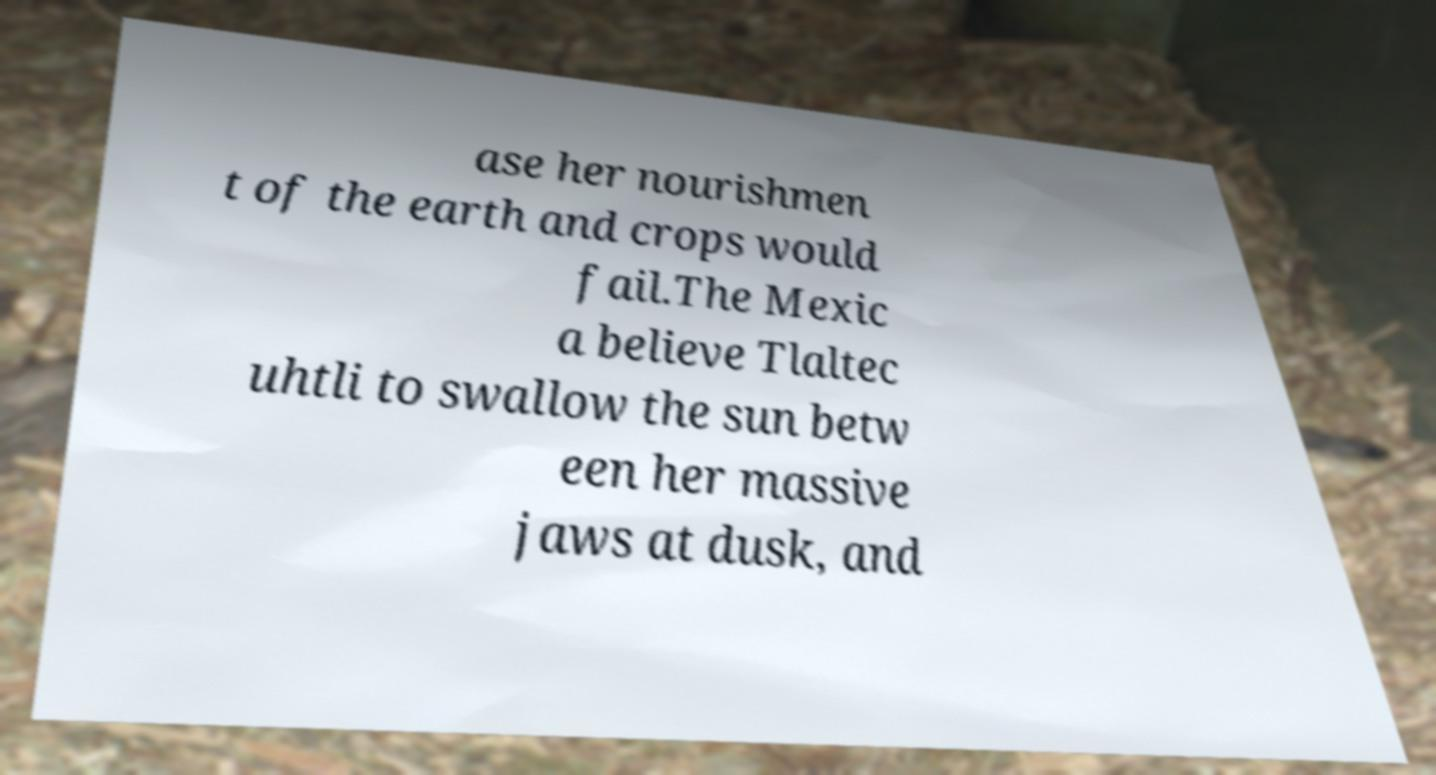I need the written content from this picture converted into text. Can you do that? ase her nourishmen t of the earth and crops would fail.The Mexic a believe Tlaltec uhtli to swallow the sun betw een her massive jaws at dusk, and 